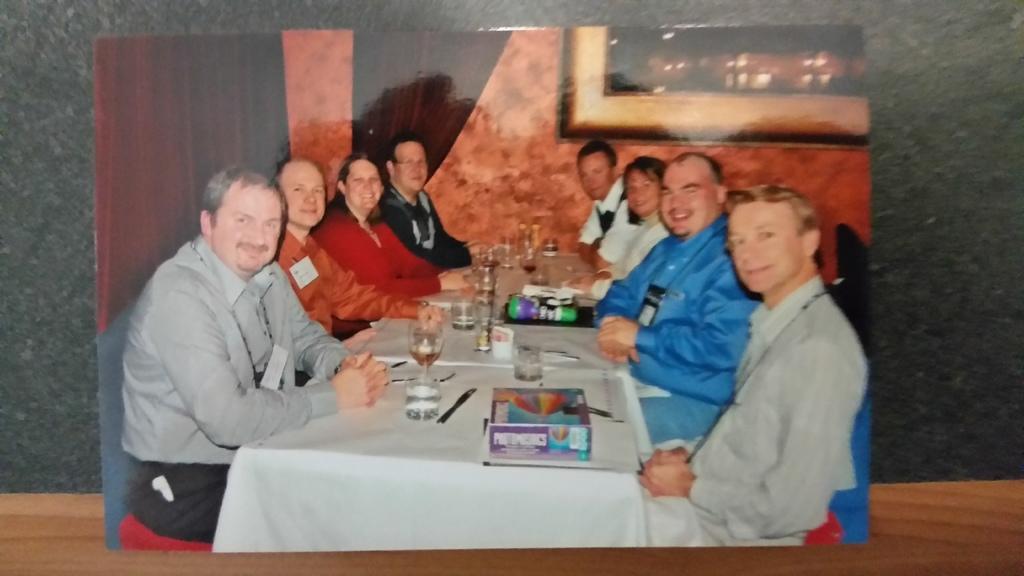How would you summarize this image in a sentence or two? it is a photograph in which people are sitting in front of a table there are many items on the table 